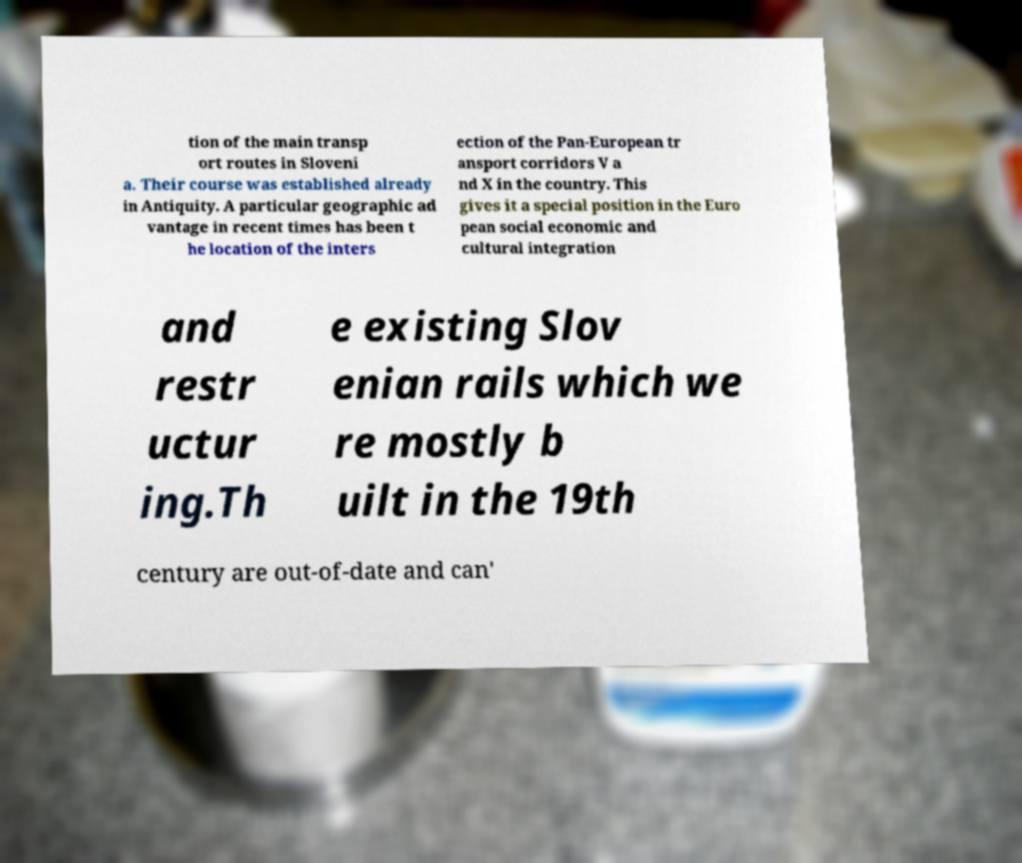Please read and relay the text visible in this image. What does it say? tion of the main transp ort routes in Sloveni a. Their course was established already in Antiquity. A particular geographic ad vantage in recent times has been t he location of the inters ection of the Pan-European tr ansport corridors V a nd X in the country. This gives it a special position in the Euro pean social economic and cultural integration and restr uctur ing.Th e existing Slov enian rails which we re mostly b uilt in the 19th century are out-of-date and can' 